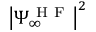Convert formula to latex. <formula><loc_0><loc_0><loc_500><loc_500>\left | \Psi _ { \infty } ^ { H F } \right | ^ { 2 }</formula> 